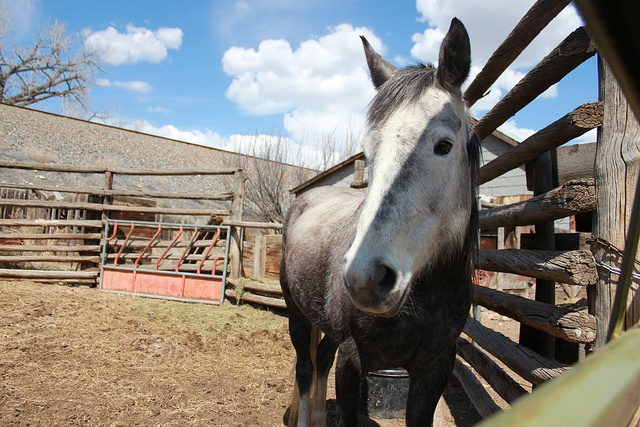Describe the objects in this image and their specific colors. I can see a horse in darkgray, black, gray, and lightgray tones in this image. 